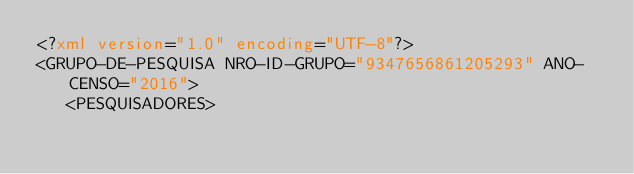Convert code to text. <code><loc_0><loc_0><loc_500><loc_500><_XML_><?xml version="1.0" encoding="UTF-8"?>
<GRUPO-DE-PESQUISA NRO-ID-GRUPO="9347656861205293" ANO-CENSO="2016">
   <PESQUISADORES></code> 